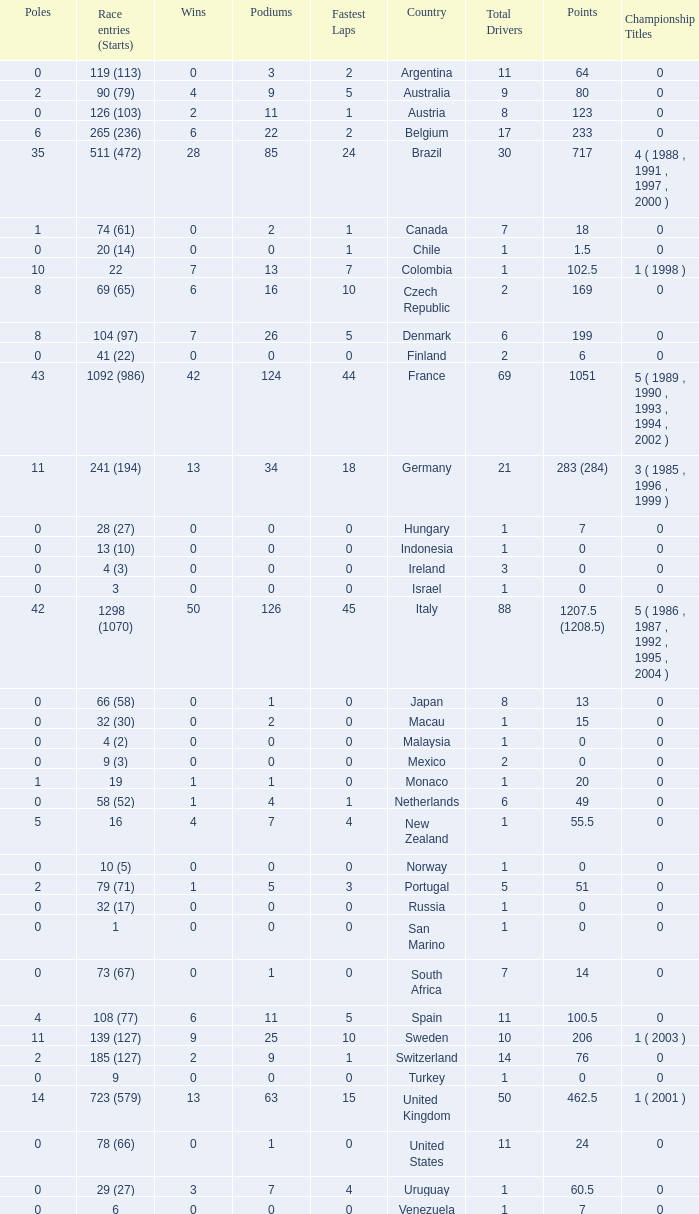Would you be able to parse every entry in this table? {'header': ['Poles', 'Race entries (Starts)', 'Wins', 'Podiums', 'Fastest Laps', 'Country', 'Total Drivers', 'Points', 'Championship Titles'], 'rows': [['0', '119 (113)', '0', '3', '2', 'Argentina', '11', '64', '0'], ['2', '90 (79)', '4', '9', '5', 'Australia', '9', '80', '0'], ['0', '126 (103)', '2', '11', '1', 'Austria', '8', '123', '0'], ['6', '265 (236)', '6', '22', '2', 'Belgium', '17', '233', '0'], ['35', '511 (472)', '28', '85', '24', 'Brazil', '30', '717', '4 ( 1988 , 1991 , 1997 , 2000 )'], ['1', '74 (61)', '0', '2', '1', 'Canada', '7', '18', '0'], ['0', '20 (14)', '0', '0', '1', 'Chile', '1', '1.5', '0'], ['10', '22', '7', '13', '7', 'Colombia', '1', '102.5', '1 ( 1998 )'], ['8', '69 (65)', '6', '16', '10', 'Czech Republic', '2', '169', '0'], ['8', '104 (97)', '7', '26', '5', 'Denmark', '6', '199', '0'], ['0', '41 (22)', '0', '0', '0', 'Finland', '2', '6', '0'], ['43', '1092 (986)', '42', '124', '44', 'France', '69', '1051', '5 ( 1989 , 1990 , 1993 , 1994 , 2002 )'], ['11', '241 (194)', '13', '34', '18', 'Germany', '21', '283 (284)', '3 ( 1985 , 1996 , 1999 )'], ['0', '28 (27)', '0', '0', '0', 'Hungary', '1', '7', '0'], ['0', '13 (10)', '0', '0', '0', 'Indonesia', '1', '0', '0'], ['0', '4 (3)', '0', '0', '0', 'Ireland', '3', '0', '0'], ['0', '3', '0', '0', '0', 'Israel', '1', '0', '0'], ['42', '1298 (1070)', '50', '126', '45', 'Italy', '88', '1207.5 (1208.5)', '5 ( 1986 , 1987 , 1992 , 1995 , 2004 )'], ['0', '66 (58)', '0', '1', '0', 'Japan', '8', '13', '0'], ['0', '32 (30)', '0', '2', '0', 'Macau', '1', '15', '0'], ['0', '4 (2)', '0', '0', '0', 'Malaysia', '1', '0', '0'], ['0', '9 (3)', '0', '0', '0', 'Mexico', '2', '0', '0'], ['1', '19', '1', '1', '0', 'Monaco', '1', '20', '0'], ['0', '58 (52)', '1', '4', '1', 'Netherlands', '6', '49', '0'], ['5', '16', '4', '7', '4', 'New Zealand', '1', '55.5', '0'], ['0', '10 (5)', '0', '0', '0', 'Norway', '1', '0', '0'], ['2', '79 (71)', '1', '5', '3', 'Portugal', '5', '51', '0'], ['0', '32 (17)', '0', '0', '0', 'Russia', '1', '0', '0'], ['0', '1', '0', '0', '0', 'San Marino', '1', '0', '0'], ['0', '73 (67)', '0', '1', '0', 'South Africa', '7', '14', '0'], ['4', '108 (77)', '6', '11', '5', 'Spain', '11', '100.5', '0'], ['11', '139 (127)', '9', '25', '10', 'Sweden', '10', '206', '1 ( 2003 )'], ['2', '185 (127)', '2', '9', '1', 'Switzerland', '14', '76', '0'], ['0', '9', '0', '0', '0', 'Turkey', '1', '0', '0'], ['14', '723 (579)', '13', '63', '15', 'United Kingdom', '50', '462.5', '1 ( 2001 )'], ['0', '78 (66)', '0', '1', '0', 'United States', '11', '24', '0'], ['0', '29 (27)', '3', '7', '4', 'Uruguay', '1', '60.5', '0'], ['0', '6', '0', '0', '0', 'Venezuela', '1', '7', '0']]} How many titles for the nation with less than 3 fastest laps and 22 podiums? 0.0. 